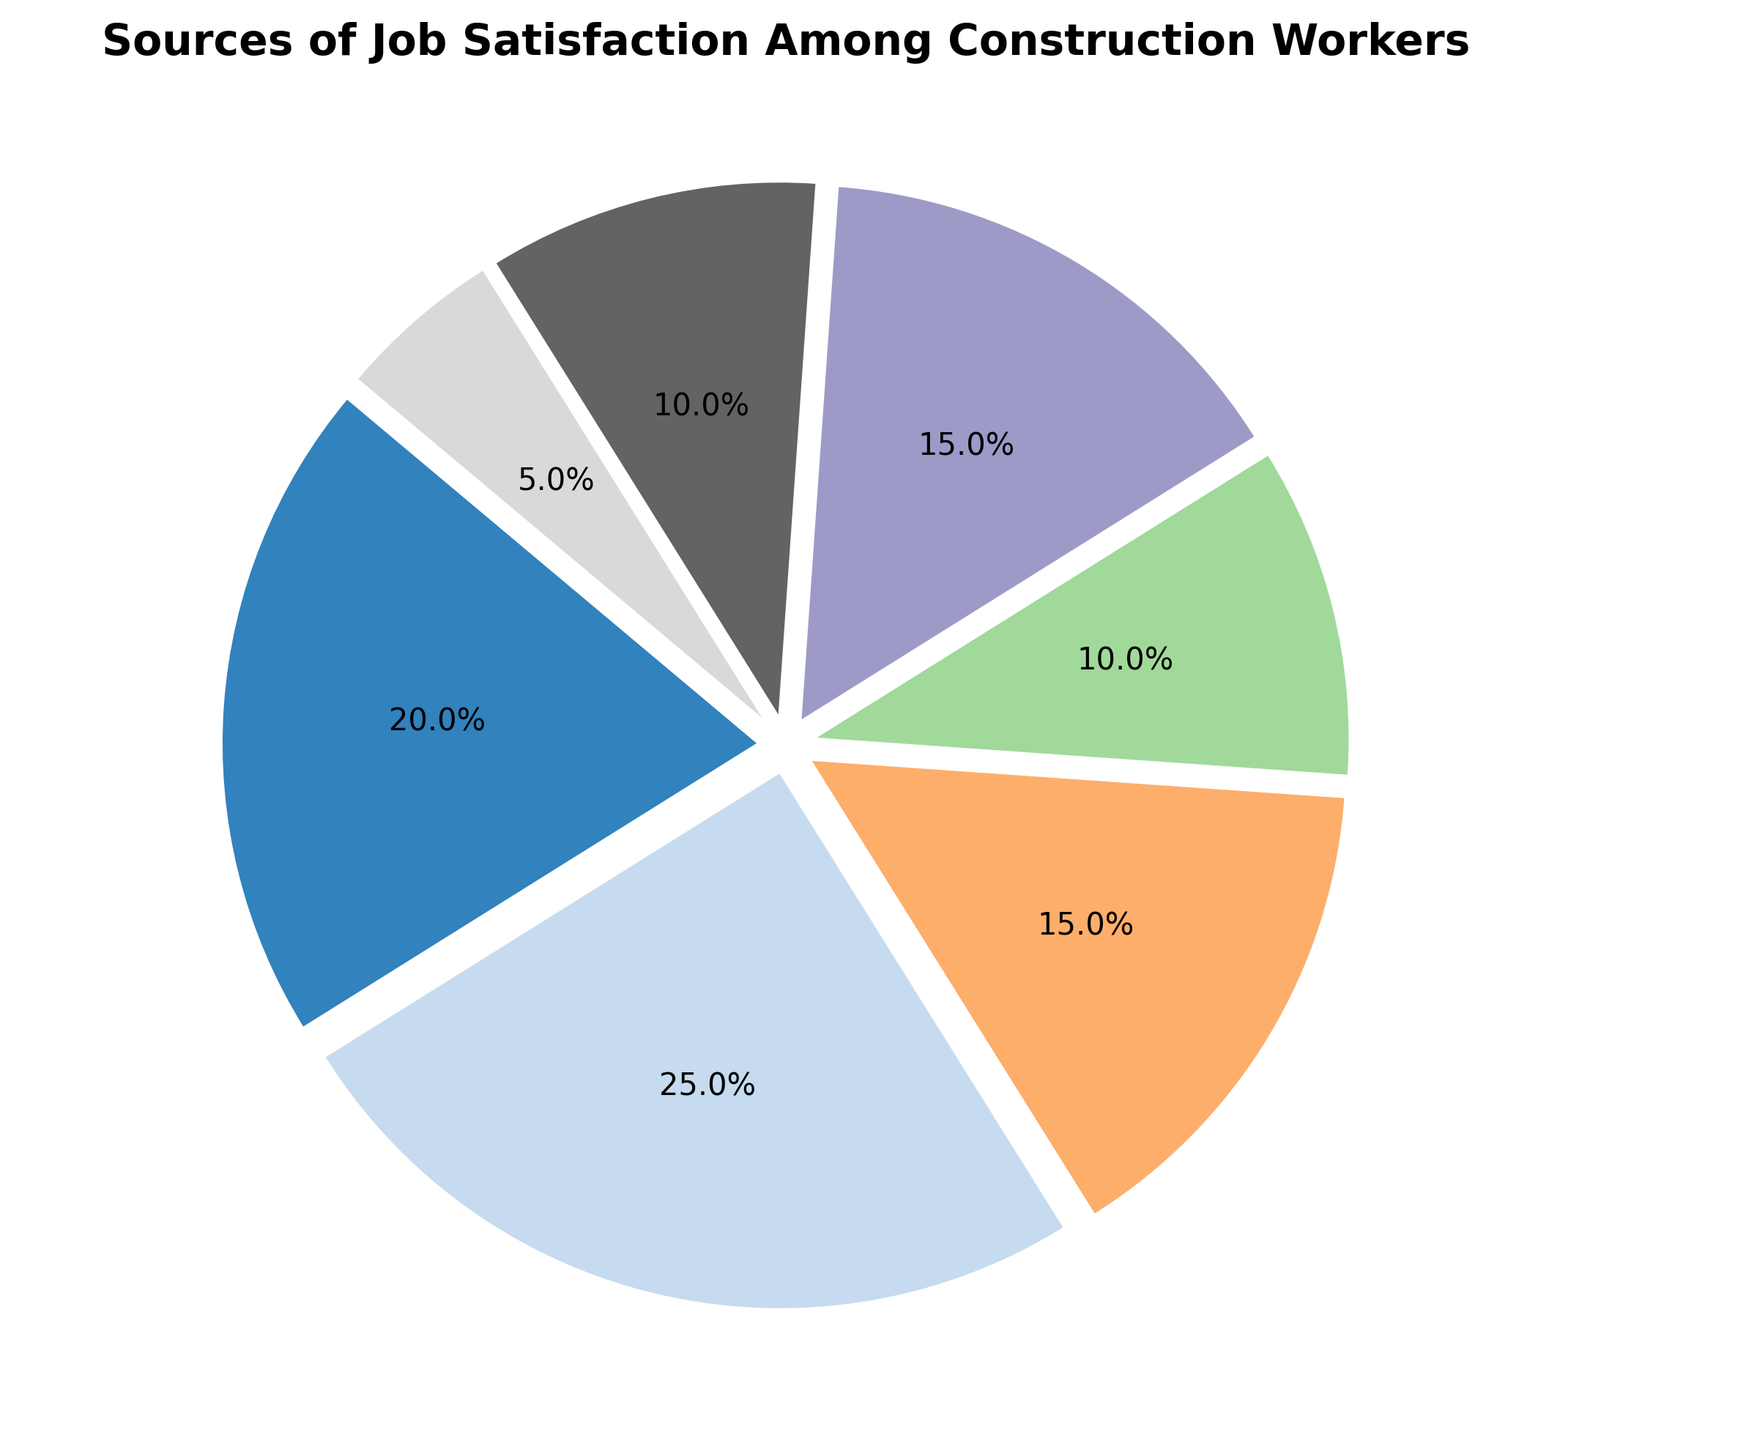What's the largest source of job satisfaction among construction workers? The largest source of job satisfaction can be identified by locating the category with the highest percentage. According to the pie chart, the "Work Environment" slice is the largest.
Answer: Work Environment What's the sum of the percentages for Job Security and Recognition and Advancement? To find the sum, add the percentages of both categories: Job Security (15%) + Recognition and Advancement (15%) = 30%.
Answer: 30% Which source contributes less to job satisfaction: Benefits and Incentives or Training Opportunities? Benefits and Incentives has a smaller percentage (5%) compared to Training Opportunities (10%).
Answer: Benefits and Incentives If you were to combine the categories Pay, Job Security, and Work-Life Balance, what fraction of job satisfaction would that make? First, sum the percentages of Pay (20%), Job Security (15%), and Work-Life Balance (10%): \(20 + 15 + 10 = 45\). Therefore, Pay, Job Security, and Work-Life Balance together represent 45%.
Answer: 45% Which categories together make up exactly half of the sources of job satisfaction? Examine combinations of categories that total 50%. For example, combining "Pay" (20%) and "Work Environment" (25%) and "Benefits and Incentives" (5%) gives \(20 + 25 + 5 = 50\). Thus these categories together sum to exactly half.
Answer: Pay, Work Environment, Benefits and Incentives What is the percentage difference between the highest and lowest sources of job satisfaction? The highest percentage is for Work Environment (25%), and the lowest is for Benefits and Incentives (5%). Subtract the lowest from the highest: \(25 - 5 = 20\).
Answer: 20% How many categories have a percentage greater than 10%? Count the slices where the percentage is greater than 10%, which are: Pay (20%), Work Environment (25%), Job Security (15%), and Recognition and Advancement (15%). Hence, there are four such categories.
Answer: 4 What would be the combined percentage for Pay, Training Opportunities, and Benefits and Incentives? Add the percentages of Pay (20%), Training Opportunities (10%), and Benefits and Incentives (5%): \(20 + 10 + 5 = 35\).
Answer: 35% How much higher is Work Environment's percentage compared to Work-Life Balance? Work Environment is 25% and Work-Life Balance is 10%. Calculate the difference: \(25 - 10 = 15\).
Answer: 15% Which category has a percentage that is equal to the sum of Benefits and Incentives and Training Opportunities? Sum the percentages of Benefits and Incentives (5%) and Training Opportunities (10%): \(5 + 10 = 15\). The category with 15% is Recognition and Advancement.
Answer: Recognition and Advancement 